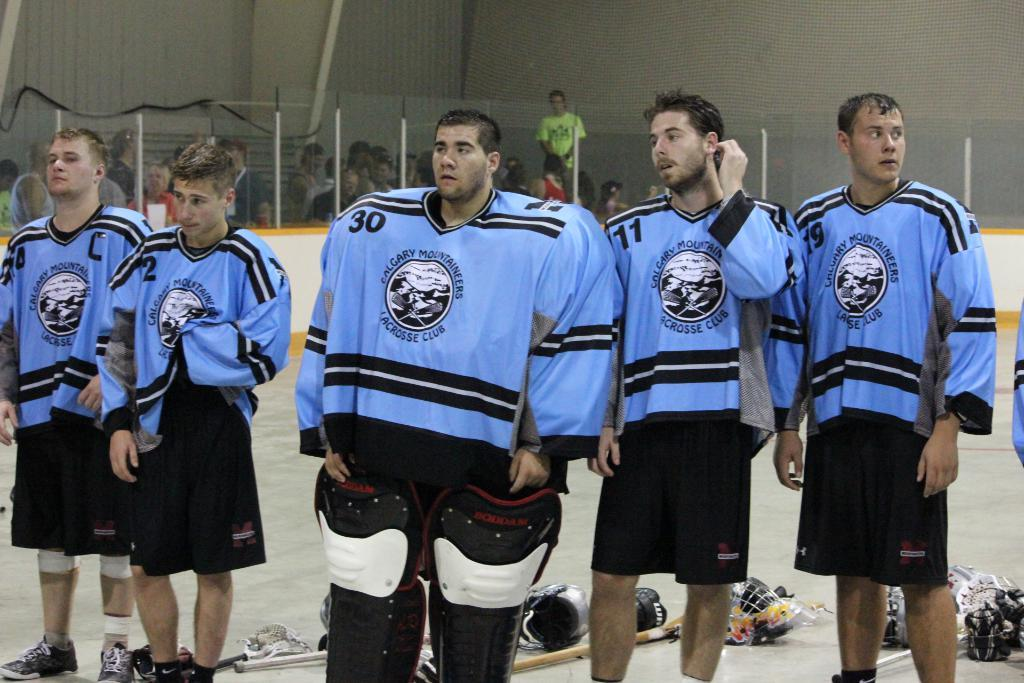<image>
Describe the image concisely. Six Calgary Mountaineers Lacrosse Club players in baby blue and black jerseys stand side by side. 